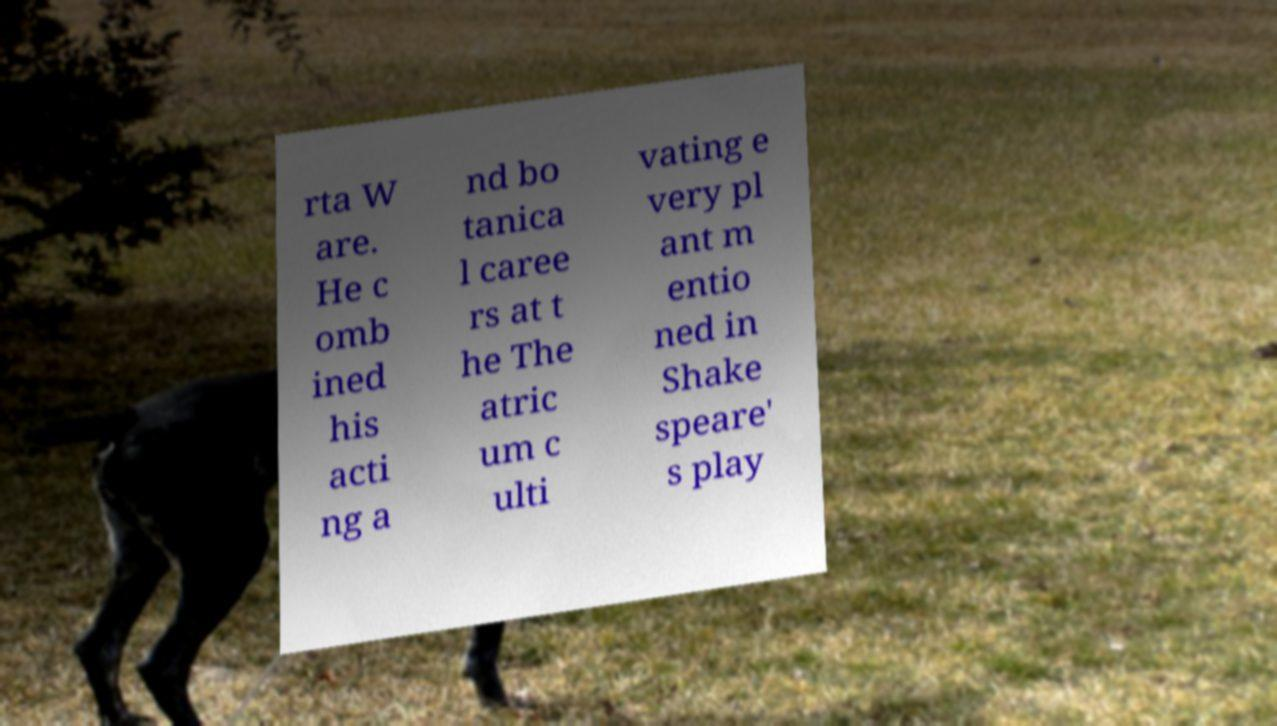Can you accurately transcribe the text from the provided image for me? rta W are. He c omb ined his acti ng a nd bo tanica l caree rs at t he The atric um c ulti vating e very pl ant m entio ned in Shake speare' s play 